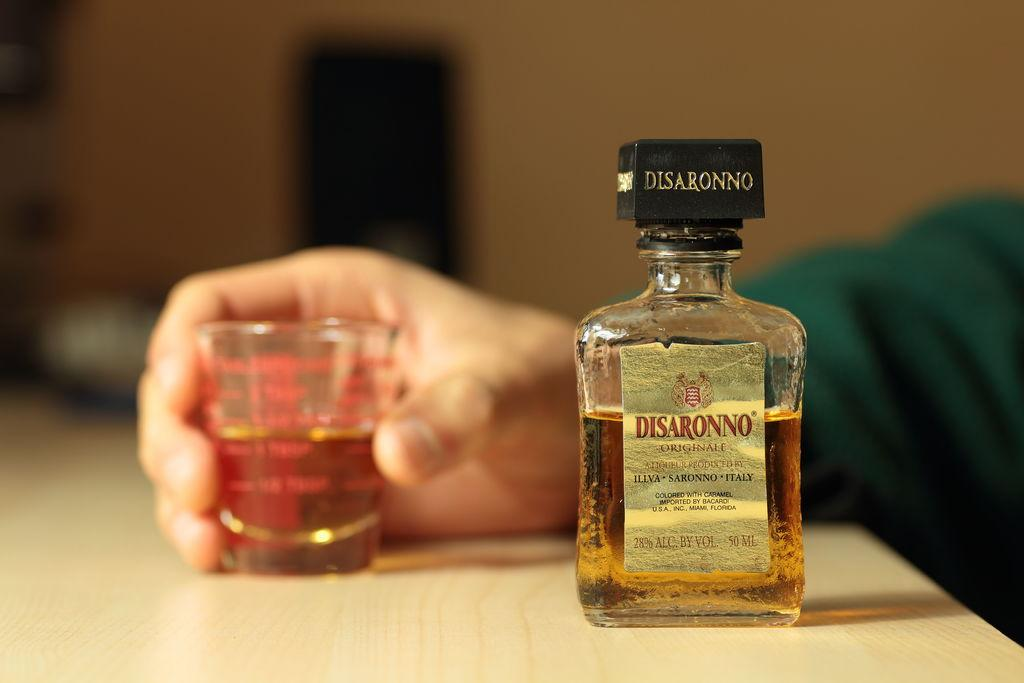What can be seen in the image related to alcohol? There is an alcohol bottle in the image. What is the man holding in the image? The man is holding a small glass in the image. Where are the bottle and the glass located? The bottle and the glass are placed on a table in the image. Can you describe the background of the image? The background of the image is blurry. What type of goose is sitting on the table next to the alcohol bottle? There is no goose present in the image; it only features a man, a small glass, and an alcohol bottle on a table. 